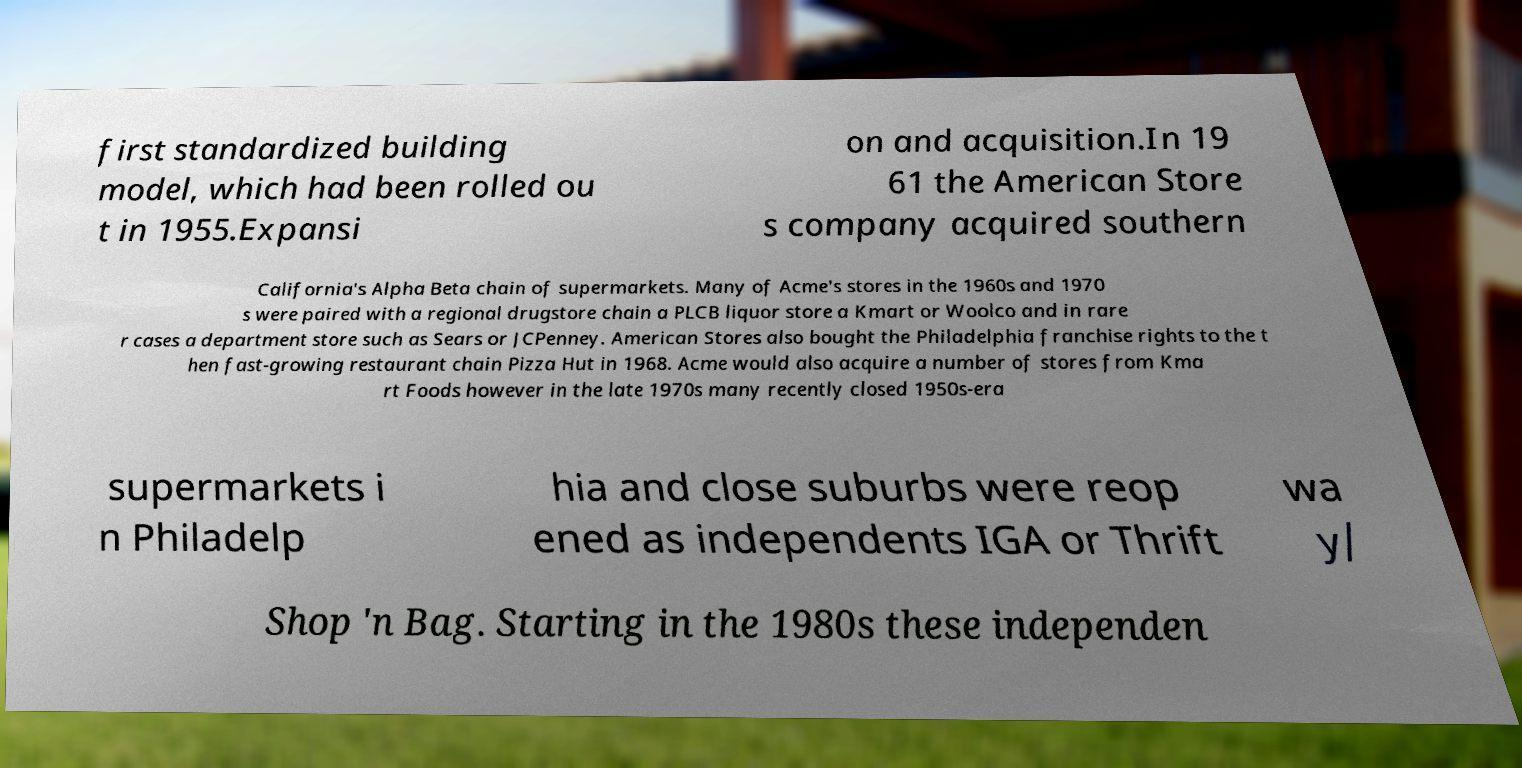I need the written content from this picture converted into text. Can you do that? first standardized building model, which had been rolled ou t in 1955.Expansi on and acquisition.In 19 61 the American Store s company acquired southern California's Alpha Beta chain of supermarkets. Many of Acme's stores in the 1960s and 1970 s were paired with a regional drugstore chain a PLCB liquor store a Kmart or Woolco and in rare r cases a department store such as Sears or JCPenney. American Stores also bought the Philadelphia franchise rights to the t hen fast-growing restaurant chain Pizza Hut in 1968. Acme would also acquire a number of stores from Kma rt Foods however in the late 1970s many recently closed 1950s-era supermarkets i n Philadelp hia and close suburbs were reop ened as independents IGA or Thrift wa y/ Shop 'n Bag. Starting in the 1980s these independen 